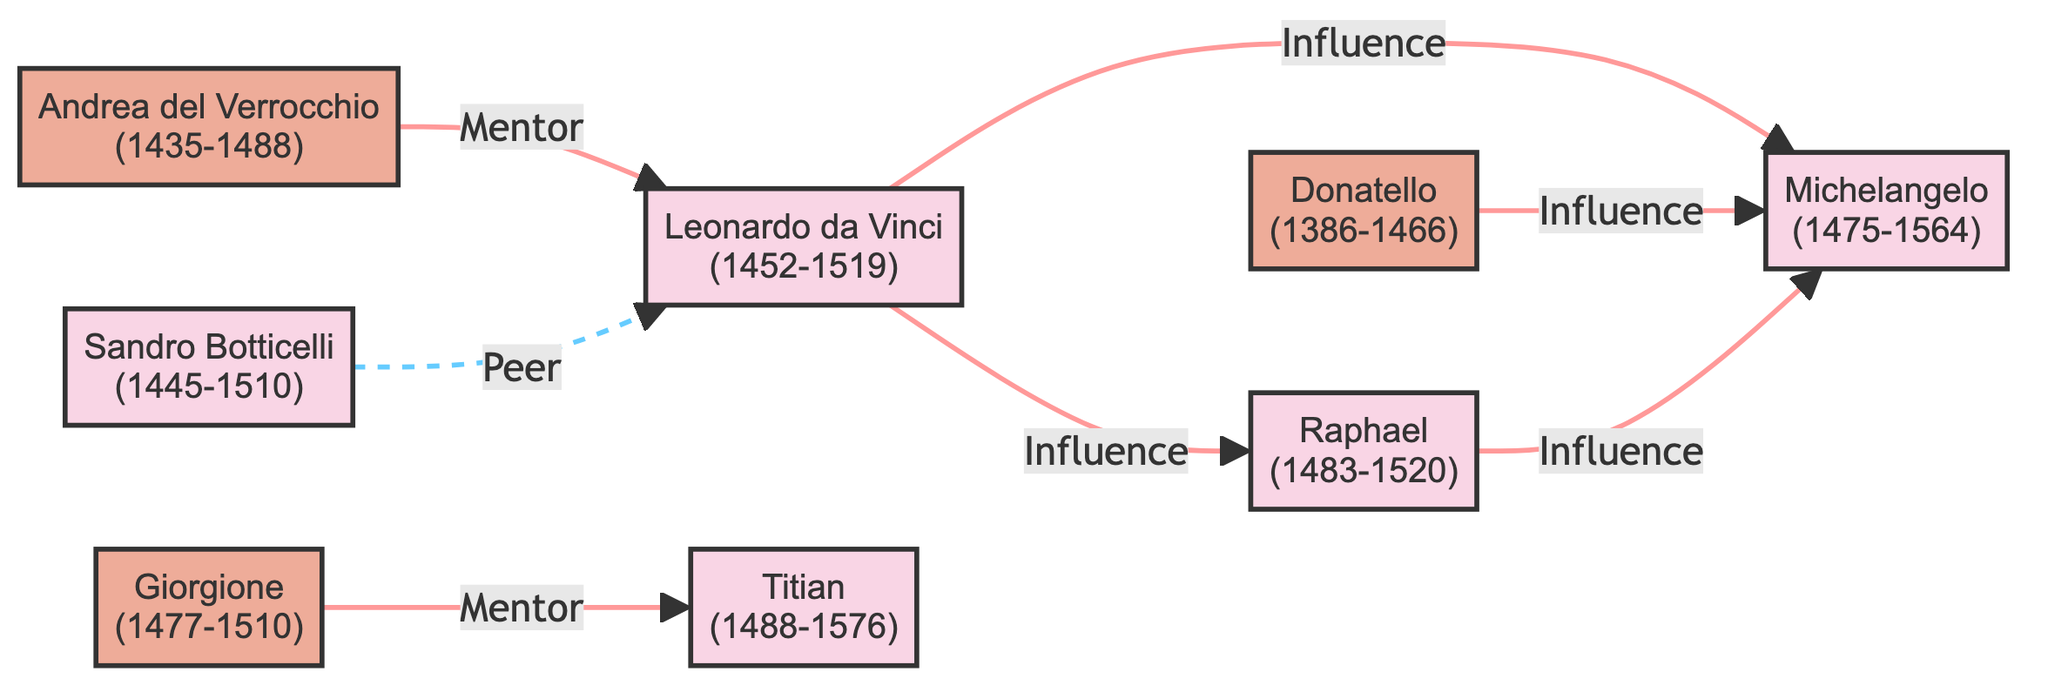What is the total number of artists in the diagram? The diagram shows nodes for each artist, and by counting them, we find there are a total of 8 artists listed.
Answer: 8 Which artist was mentored by Andrea del Verrocchio? According to the diagram, Leonardo da Vinci is the only artist that has a direct connection labeled "Mentor" from Andrea del Verrocchio.
Answer: Leonardo da Vinci How many artists influenced Michelangelo? The diagram displays two edges pointing towards Michelangelo from other artists, specifically Leonardo da Vinci and Donatello, indicating they both influenced him.
Answer: 2 What is the relationship between Giorgione and Titian? The edge connecting Giorgione and Titian is labeled "Mentor," which signifies that Giorgione is a mentor to Titian.
Answer: Mentor Who influenced Raphael? The diagram shows an edge going from Leonardo da Vinci to Raphael labeled "Influence," indicating that Leonardo da Vinci influenced Raphael.
Answer: Leonardo da Vinci Which artist has the most connections in the diagram? By examining the diagram, we find that Leonardo da Vinci has three connections: one peer from Sandro Botticelli and two influences—one each from Michelangelo and Raphael. Therefore, he has the most connections.
Answer: Leonardo da Vinci What type of relationship does Sandro Botticelli have with Leonardo da Vinci? The diagram indicates that the line between Sandro Botticelli and Leonardo da Vinci is a dashed line labeled "Peer," depicting their relationship as peers rather than a mentor or influencer.
Answer: Peer Which artist was born first, Donatello or Titian? By looking at the birth years in the diagram, Donatello was born in 1386, while Titian was born in 1488, making Donatello the earlier born artist.
Answer: Donatello 